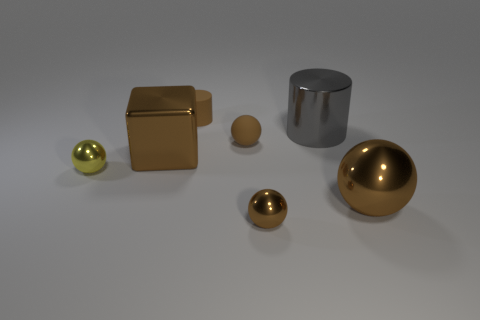How many brown balls must be subtracted to get 1 brown balls? 2 Subtract all small spheres. How many spheres are left? 1 Add 2 large red metallic cylinders. How many objects exist? 9 Subtract all yellow balls. How many balls are left? 3 Subtract all blocks. How many objects are left? 6 Subtract all brown cubes. How many brown spheres are left? 3 Add 4 spheres. How many spheres are left? 8 Add 5 large brown metal spheres. How many large brown metal spheres exist? 6 Subtract 0 purple cylinders. How many objects are left? 7 Subtract all green cylinders. Subtract all gray spheres. How many cylinders are left? 2 